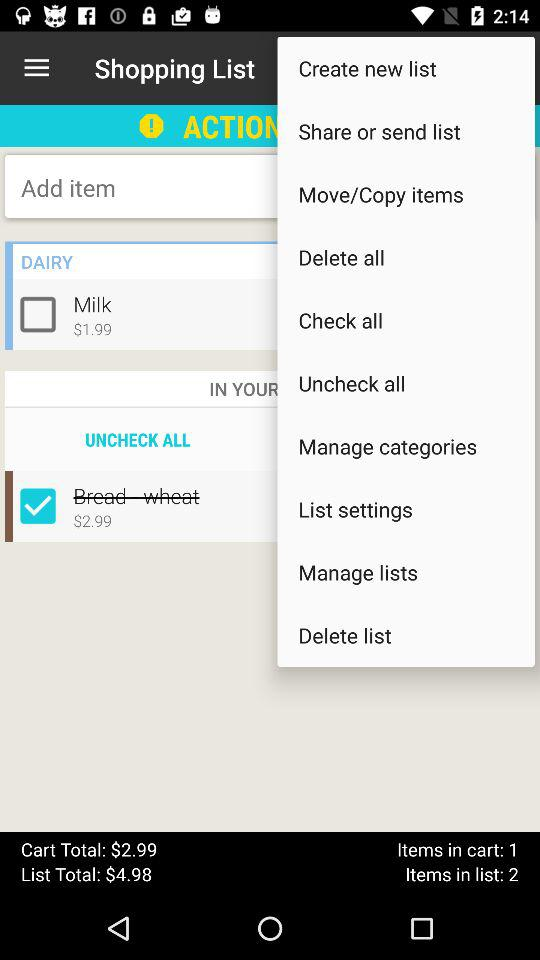How much is the list total? The list total is $4.98. 